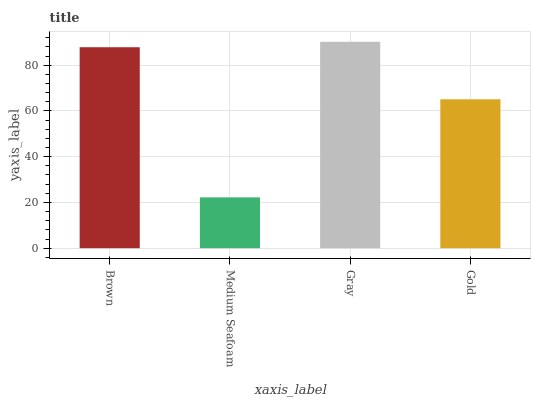Is Medium Seafoam the minimum?
Answer yes or no. Yes. Is Gray the maximum?
Answer yes or no. Yes. Is Gray the minimum?
Answer yes or no. No. Is Medium Seafoam the maximum?
Answer yes or no. No. Is Gray greater than Medium Seafoam?
Answer yes or no. Yes. Is Medium Seafoam less than Gray?
Answer yes or no. Yes. Is Medium Seafoam greater than Gray?
Answer yes or no. No. Is Gray less than Medium Seafoam?
Answer yes or no. No. Is Brown the high median?
Answer yes or no. Yes. Is Gold the low median?
Answer yes or no. Yes. Is Gray the high median?
Answer yes or no. No. Is Gray the low median?
Answer yes or no. No. 